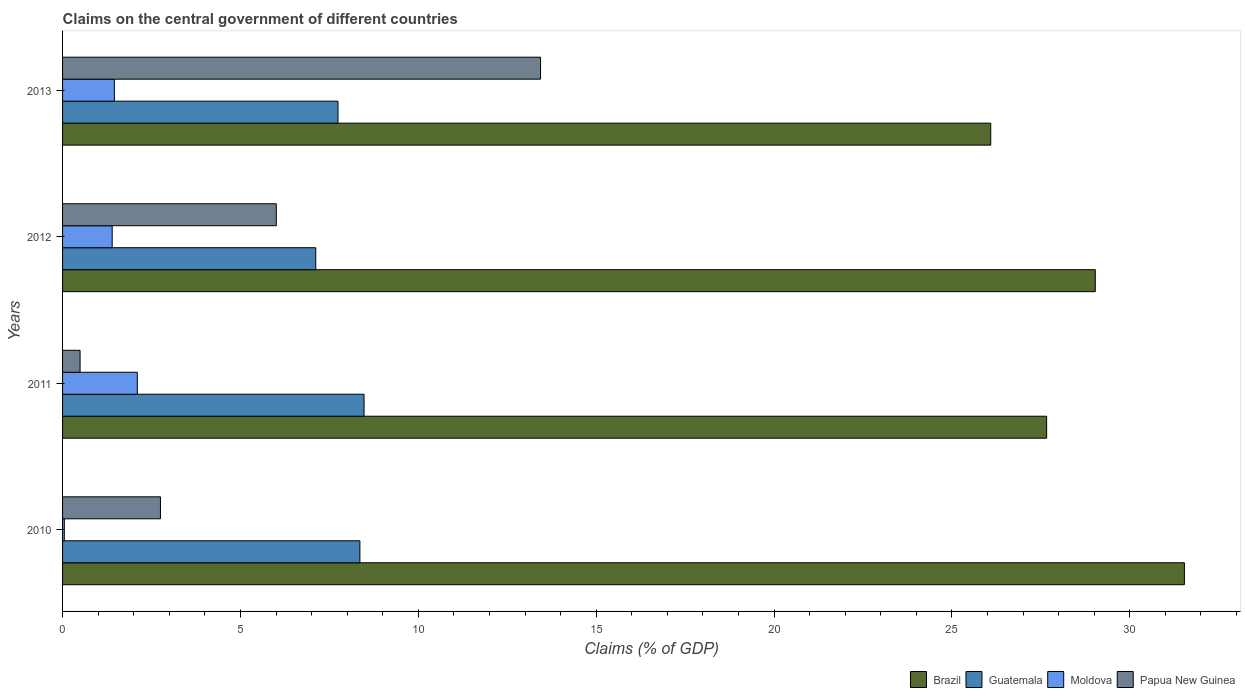How many different coloured bars are there?
Provide a succinct answer. 4. How many groups of bars are there?
Your answer should be very brief. 4. Are the number of bars on each tick of the Y-axis equal?
Your answer should be compact. Yes. How many bars are there on the 4th tick from the top?
Provide a succinct answer. 4. How many bars are there on the 3rd tick from the bottom?
Give a very brief answer. 4. What is the label of the 1st group of bars from the top?
Ensure brevity in your answer.  2013. What is the percentage of GDP claimed on the central government in Guatemala in 2010?
Your response must be concise. 8.36. Across all years, what is the maximum percentage of GDP claimed on the central government in Guatemala?
Keep it short and to the point. 8.47. Across all years, what is the minimum percentage of GDP claimed on the central government in Guatemala?
Give a very brief answer. 7.12. In which year was the percentage of GDP claimed on the central government in Guatemala maximum?
Provide a short and direct response. 2011. In which year was the percentage of GDP claimed on the central government in Brazil minimum?
Make the answer very short. 2013. What is the total percentage of GDP claimed on the central government in Moldova in the graph?
Provide a short and direct response. 5. What is the difference between the percentage of GDP claimed on the central government in Papua New Guinea in 2010 and that in 2013?
Provide a succinct answer. -10.68. What is the difference between the percentage of GDP claimed on the central government in Brazil in 2011 and the percentage of GDP claimed on the central government in Guatemala in 2013?
Give a very brief answer. 19.92. What is the average percentage of GDP claimed on the central government in Guatemala per year?
Provide a short and direct response. 7.92. In the year 2010, what is the difference between the percentage of GDP claimed on the central government in Guatemala and percentage of GDP claimed on the central government in Moldova?
Provide a succinct answer. 8.31. In how many years, is the percentage of GDP claimed on the central government in Moldova greater than 32 %?
Provide a succinct answer. 0. What is the ratio of the percentage of GDP claimed on the central government in Guatemala in 2010 to that in 2013?
Offer a terse response. 1.08. Is the percentage of GDP claimed on the central government in Brazil in 2010 less than that in 2012?
Provide a succinct answer. No. What is the difference between the highest and the second highest percentage of GDP claimed on the central government in Papua New Guinea?
Offer a terse response. 7.43. What is the difference between the highest and the lowest percentage of GDP claimed on the central government in Guatemala?
Your answer should be very brief. 1.36. In how many years, is the percentage of GDP claimed on the central government in Papua New Guinea greater than the average percentage of GDP claimed on the central government in Papua New Guinea taken over all years?
Your answer should be compact. 2. Is the sum of the percentage of GDP claimed on the central government in Guatemala in 2012 and 2013 greater than the maximum percentage of GDP claimed on the central government in Papua New Guinea across all years?
Provide a succinct answer. Yes. What does the 1st bar from the top in 2011 represents?
Offer a very short reply. Papua New Guinea. What does the 2nd bar from the bottom in 2012 represents?
Your response must be concise. Guatemala. Is it the case that in every year, the sum of the percentage of GDP claimed on the central government in Guatemala and percentage of GDP claimed on the central government in Papua New Guinea is greater than the percentage of GDP claimed on the central government in Moldova?
Keep it short and to the point. Yes. How many bars are there?
Offer a very short reply. 16. What is the difference between two consecutive major ticks on the X-axis?
Keep it short and to the point. 5. How are the legend labels stacked?
Keep it short and to the point. Horizontal. What is the title of the graph?
Your answer should be compact. Claims on the central government of different countries. What is the label or title of the X-axis?
Provide a succinct answer. Claims (% of GDP). What is the label or title of the Y-axis?
Your response must be concise. Years. What is the Claims (% of GDP) of Brazil in 2010?
Your answer should be compact. 31.53. What is the Claims (% of GDP) of Guatemala in 2010?
Provide a short and direct response. 8.36. What is the Claims (% of GDP) of Moldova in 2010?
Provide a succinct answer. 0.05. What is the Claims (% of GDP) of Papua New Guinea in 2010?
Ensure brevity in your answer.  2.75. What is the Claims (% of GDP) of Brazil in 2011?
Provide a short and direct response. 27.66. What is the Claims (% of GDP) in Guatemala in 2011?
Make the answer very short. 8.47. What is the Claims (% of GDP) in Moldova in 2011?
Ensure brevity in your answer.  2.1. What is the Claims (% of GDP) of Papua New Guinea in 2011?
Provide a short and direct response. 0.49. What is the Claims (% of GDP) in Brazil in 2012?
Provide a short and direct response. 29.03. What is the Claims (% of GDP) of Guatemala in 2012?
Provide a succinct answer. 7.12. What is the Claims (% of GDP) in Moldova in 2012?
Provide a short and direct response. 1.39. What is the Claims (% of GDP) in Papua New Guinea in 2012?
Provide a short and direct response. 6.01. What is the Claims (% of GDP) in Brazil in 2013?
Your answer should be very brief. 26.09. What is the Claims (% of GDP) of Guatemala in 2013?
Ensure brevity in your answer.  7.74. What is the Claims (% of GDP) in Moldova in 2013?
Your answer should be very brief. 1.46. What is the Claims (% of GDP) of Papua New Guinea in 2013?
Offer a very short reply. 13.44. Across all years, what is the maximum Claims (% of GDP) of Brazil?
Provide a succinct answer. 31.53. Across all years, what is the maximum Claims (% of GDP) in Guatemala?
Your answer should be compact. 8.47. Across all years, what is the maximum Claims (% of GDP) in Moldova?
Your answer should be compact. 2.1. Across all years, what is the maximum Claims (% of GDP) in Papua New Guinea?
Ensure brevity in your answer.  13.44. Across all years, what is the minimum Claims (% of GDP) in Brazil?
Offer a terse response. 26.09. Across all years, what is the minimum Claims (% of GDP) in Guatemala?
Keep it short and to the point. 7.12. Across all years, what is the minimum Claims (% of GDP) in Moldova?
Offer a very short reply. 0.05. Across all years, what is the minimum Claims (% of GDP) in Papua New Guinea?
Ensure brevity in your answer.  0.49. What is the total Claims (% of GDP) of Brazil in the graph?
Your answer should be compact. 114.32. What is the total Claims (% of GDP) of Guatemala in the graph?
Your response must be concise. 31.69. What is the total Claims (% of GDP) in Moldova in the graph?
Provide a short and direct response. 5. What is the total Claims (% of GDP) of Papua New Guinea in the graph?
Your answer should be compact. 22.69. What is the difference between the Claims (% of GDP) in Brazil in 2010 and that in 2011?
Your response must be concise. 3.87. What is the difference between the Claims (% of GDP) of Guatemala in 2010 and that in 2011?
Make the answer very short. -0.12. What is the difference between the Claims (% of GDP) of Moldova in 2010 and that in 2011?
Your response must be concise. -2.05. What is the difference between the Claims (% of GDP) in Papua New Guinea in 2010 and that in 2011?
Your answer should be compact. 2.26. What is the difference between the Claims (% of GDP) of Brazil in 2010 and that in 2012?
Offer a terse response. 2.51. What is the difference between the Claims (% of GDP) of Guatemala in 2010 and that in 2012?
Provide a short and direct response. 1.24. What is the difference between the Claims (% of GDP) of Moldova in 2010 and that in 2012?
Your answer should be very brief. -1.35. What is the difference between the Claims (% of GDP) in Papua New Guinea in 2010 and that in 2012?
Provide a succinct answer. -3.26. What is the difference between the Claims (% of GDP) of Brazil in 2010 and that in 2013?
Your answer should be very brief. 5.44. What is the difference between the Claims (% of GDP) of Guatemala in 2010 and that in 2013?
Offer a very short reply. 0.62. What is the difference between the Claims (% of GDP) in Moldova in 2010 and that in 2013?
Your answer should be very brief. -1.41. What is the difference between the Claims (% of GDP) in Papua New Guinea in 2010 and that in 2013?
Your answer should be very brief. -10.68. What is the difference between the Claims (% of GDP) of Brazil in 2011 and that in 2012?
Your answer should be compact. -1.37. What is the difference between the Claims (% of GDP) of Guatemala in 2011 and that in 2012?
Offer a very short reply. 1.36. What is the difference between the Claims (% of GDP) in Moldova in 2011 and that in 2012?
Offer a very short reply. 0.71. What is the difference between the Claims (% of GDP) of Papua New Guinea in 2011 and that in 2012?
Ensure brevity in your answer.  -5.52. What is the difference between the Claims (% of GDP) of Brazil in 2011 and that in 2013?
Provide a short and direct response. 1.57. What is the difference between the Claims (% of GDP) of Guatemala in 2011 and that in 2013?
Keep it short and to the point. 0.73. What is the difference between the Claims (% of GDP) of Moldova in 2011 and that in 2013?
Make the answer very short. 0.64. What is the difference between the Claims (% of GDP) in Papua New Guinea in 2011 and that in 2013?
Give a very brief answer. -12.94. What is the difference between the Claims (% of GDP) in Brazil in 2012 and that in 2013?
Your answer should be very brief. 2.94. What is the difference between the Claims (% of GDP) in Guatemala in 2012 and that in 2013?
Provide a short and direct response. -0.63. What is the difference between the Claims (% of GDP) in Moldova in 2012 and that in 2013?
Give a very brief answer. -0.06. What is the difference between the Claims (% of GDP) of Papua New Guinea in 2012 and that in 2013?
Your answer should be compact. -7.43. What is the difference between the Claims (% of GDP) in Brazil in 2010 and the Claims (% of GDP) in Guatemala in 2011?
Provide a succinct answer. 23.06. What is the difference between the Claims (% of GDP) of Brazil in 2010 and the Claims (% of GDP) of Moldova in 2011?
Provide a succinct answer. 29.43. What is the difference between the Claims (% of GDP) of Brazil in 2010 and the Claims (% of GDP) of Papua New Guinea in 2011?
Keep it short and to the point. 31.04. What is the difference between the Claims (% of GDP) in Guatemala in 2010 and the Claims (% of GDP) in Moldova in 2011?
Provide a succinct answer. 6.26. What is the difference between the Claims (% of GDP) in Guatemala in 2010 and the Claims (% of GDP) in Papua New Guinea in 2011?
Provide a short and direct response. 7.87. What is the difference between the Claims (% of GDP) of Moldova in 2010 and the Claims (% of GDP) of Papua New Guinea in 2011?
Your answer should be very brief. -0.44. What is the difference between the Claims (% of GDP) in Brazil in 2010 and the Claims (% of GDP) in Guatemala in 2012?
Make the answer very short. 24.42. What is the difference between the Claims (% of GDP) of Brazil in 2010 and the Claims (% of GDP) of Moldova in 2012?
Your response must be concise. 30.14. What is the difference between the Claims (% of GDP) of Brazil in 2010 and the Claims (% of GDP) of Papua New Guinea in 2012?
Your response must be concise. 25.53. What is the difference between the Claims (% of GDP) of Guatemala in 2010 and the Claims (% of GDP) of Moldova in 2012?
Offer a very short reply. 6.96. What is the difference between the Claims (% of GDP) of Guatemala in 2010 and the Claims (% of GDP) of Papua New Guinea in 2012?
Keep it short and to the point. 2.35. What is the difference between the Claims (% of GDP) of Moldova in 2010 and the Claims (% of GDP) of Papua New Guinea in 2012?
Make the answer very short. -5.96. What is the difference between the Claims (% of GDP) of Brazil in 2010 and the Claims (% of GDP) of Guatemala in 2013?
Your answer should be compact. 23.79. What is the difference between the Claims (% of GDP) in Brazil in 2010 and the Claims (% of GDP) in Moldova in 2013?
Provide a succinct answer. 30.08. What is the difference between the Claims (% of GDP) in Brazil in 2010 and the Claims (% of GDP) in Papua New Guinea in 2013?
Ensure brevity in your answer.  18.1. What is the difference between the Claims (% of GDP) in Guatemala in 2010 and the Claims (% of GDP) in Moldova in 2013?
Ensure brevity in your answer.  6.9. What is the difference between the Claims (% of GDP) of Guatemala in 2010 and the Claims (% of GDP) of Papua New Guinea in 2013?
Make the answer very short. -5.08. What is the difference between the Claims (% of GDP) of Moldova in 2010 and the Claims (% of GDP) of Papua New Guinea in 2013?
Provide a succinct answer. -13.39. What is the difference between the Claims (% of GDP) of Brazil in 2011 and the Claims (% of GDP) of Guatemala in 2012?
Provide a succinct answer. 20.54. What is the difference between the Claims (% of GDP) in Brazil in 2011 and the Claims (% of GDP) in Moldova in 2012?
Make the answer very short. 26.27. What is the difference between the Claims (% of GDP) in Brazil in 2011 and the Claims (% of GDP) in Papua New Guinea in 2012?
Keep it short and to the point. 21.65. What is the difference between the Claims (% of GDP) of Guatemala in 2011 and the Claims (% of GDP) of Moldova in 2012?
Your answer should be very brief. 7.08. What is the difference between the Claims (% of GDP) in Guatemala in 2011 and the Claims (% of GDP) in Papua New Guinea in 2012?
Your response must be concise. 2.47. What is the difference between the Claims (% of GDP) of Moldova in 2011 and the Claims (% of GDP) of Papua New Guinea in 2012?
Your answer should be compact. -3.91. What is the difference between the Claims (% of GDP) of Brazil in 2011 and the Claims (% of GDP) of Guatemala in 2013?
Your response must be concise. 19.92. What is the difference between the Claims (% of GDP) in Brazil in 2011 and the Claims (% of GDP) in Moldova in 2013?
Your response must be concise. 26.21. What is the difference between the Claims (% of GDP) of Brazil in 2011 and the Claims (% of GDP) of Papua New Guinea in 2013?
Your answer should be very brief. 14.23. What is the difference between the Claims (% of GDP) of Guatemala in 2011 and the Claims (% of GDP) of Moldova in 2013?
Offer a terse response. 7.02. What is the difference between the Claims (% of GDP) in Guatemala in 2011 and the Claims (% of GDP) in Papua New Guinea in 2013?
Give a very brief answer. -4.96. What is the difference between the Claims (% of GDP) of Moldova in 2011 and the Claims (% of GDP) of Papua New Guinea in 2013?
Keep it short and to the point. -11.33. What is the difference between the Claims (% of GDP) in Brazil in 2012 and the Claims (% of GDP) in Guatemala in 2013?
Keep it short and to the point. 21.29. What is the difference between the Claims (% of GDP) of Brazil in 2012 and the Claims (% of GDP) of Moldova in 2013?
Provide a succinct answer. 27.57. What is the difference between the Claims (% of GDP) of Brazil in 2012 and the Claims (% of GDP) of Papua New Guinea in 2013?
Keep it short and to the point. 15.59. What is the difference between the Claims (% of GDP) of Guatemala in 2012 and the Claims (% of GDP) of Moldova in 2013?
Provide a succinct answer. 5.66. What is the difference between the Claims (% of GDP) of Guatemala in 2012 and the Claims (% of GDP) of Papua New Guinea in 2013?
Offer a very short reply. -6.32. What is the difference between the Claims (% of GDP) of Moldova in 2012 and the Claims (% of GDP) of Papua New Guinea in 2013?
Offer a very short reply. -12.04. What is the average Claims (% of GDP) of Brazil per year?
Your answer should be compact. 28.58. What is the average Claims (% of GDP) of Guatemala per year?
Give a very brief answer. 7.92. What is the average Claims (% of GDP) of Moldova per year?
Give a very brief answer. 1.25. What is the average Claims (% of GDP) of Papua New Guinea per year?
Ensure brevity in your answer.  5.67. In the year 2010, what is the difference between the Claims (% of GDP) of Brazil and Claims (% of GDP) of Guatemala?
Offer a terse response. 23.18. In the year 2010, what is the difference between the Claims (% of GDP) of Brazil and Claims (% of GDP) of Moldova?
Ensure brevity in your answer.  31.48. In the year 2010, what is the difference between the Claims (% of GDP) in Brazil and Claims (% of GDP) in Papua New Guinea?
Make the answer very short. 28.78. In the year 2010, what is the difference between the Claims (% of GDP) of Guatemala and Claims (% of GDP) of Moldova?
Offer a terse response. 8.31. In the year 2010, what is the difference between the Claims (% of GDP) in Guatemala and Claims (% of GDP) in Papua New Guinea?
Ensure brevity in your answer.  5.61. In the year 2010, what is the difference between the Claims (% of GDP) of Moldova and Claims (% of GDP) of Papua New Guinea?
Your response must be concise. -2.7. In the year 2011, what is the difference between the Claims (% of GDP) of Brazil and Claims (% of GDP) of Guatemala?
Your answer should be very brief. 19.19. In the year 2011, what is the difference between the Claims (% of GDP) in Brazil and Claims (% of GDP) in Moldova?
Your response must be concise. 25.56. In the year 2011, what is the difference between the Claims (% of GDP) of Brazil and Claims (% of GDP) of Papua New Guinea?
Offer a very short reply. 27.17. In the year 2011, what is the difference between the Claims (% of GDP) of Guatemala and Claims (% of GDP) of Moldova?
Offer a terse response. 6.37. In the year 2011, what is the difference between the Claims (% of GDP) of Guatemala and Claims (% of GDP) of Papua New Guinea?
Offer a terse response. 7.98. In the year 2011, what is the difference between the Claims (% of GDP) in Moldova and Claims (% of GDP) in Papua New Guinea?
Keep it short and to the point. 1.61. In the year 2012, what is the difference between the Claims (% of GDP) of Brazil and Claims (% of GDP) of Guatemala?
Offer a very short reply. 21.91. In the year 2012, what is the difference between the Claims (% of GDP) of Brazil and Claims (% of GDP) of Moldova?
Ensure brevity in your answer.  27.63. In the year 2012, what is the difference between the Claims (% of GDP) of Brazil and Claims (% of GDP) of Papua New Guinea?
Offer a very short reply. 23.02. In the year 2012, what is the difference between the Claims (% of GDP) of Guatemala and Claims (% of GDP) of Moldova?
Your answer should be very brief. 5.72. In the year 2012, what is the difference between the Claims (% of GDP) of Guatemala and Claims (% of GDP) of Papua New Guinea?
Your answer should be very brief. 1.11. In the year 2012, what is the difference between the Claims (% of GDP) in Moldova and Claims (% of GDP) in Papua New Guinea?
Your answer should be very brief. -4.61. In the year 2013, what is the difference between the Claims (% of GDP) in Brazil and Claims (% of GDP) in Guatemala?
Keep it short and to the point. 18.35. In the year 2013, what is the difference between the Claims (% of GDP) of Brazil and Claims (% of GDP) of Moldova?
Offer a terse response. 24.63. In the year 2013, what is the difference between the Claims (% of GDP) of Brazil and Claims (% of GDP) of Papua New Guinea?
Offer a very short reply. 12.65. In the year 2013, what is the difference between the Claims (% of GDP) in Guatemala and Claims (% of GDP) in Moldova?
Your answer should be compact. 6.29. In the year 2013, what is the difference between the Claims (% of GDP) in Guatemala and Claims (% of GDP) in Papua New Guinea?
Make the answer very short. -5.69. In the year 2013, what is the difference between the Claims (% of GDP) in Moldova and Claims (% of GDP) in Papua New Guinea?
Give a very brief answer. -11.98. What is the ratio of the Claims (% of GDP) in Brazil in 2010 to that in 2011?
Your answer should be compact. 1.14. What is the ratio of the Claims (% of GDP) in Guatemala in 2010 to that in 2011?
Offer a very short reply. 0.99. What is the ratio of the Claims (% of GDP) in Moldova in 2010 to that in 2011?
Your response must be concise. 0.02. What is the ratio of the Claims (% of GDP) in Papua New Guinea in 2010 to that in 2011?
Give a very brief answer. 5.59. What is the ratio of the Claims (% of GDP) of Brazil in 2010 to that in 2012?
Make the answer very short. 1.09. What is the ratio of the Claims (% of GDP) in Guatemala in 2010 to that in 2012?
Make the answer very short. 1.17. What is the ratio of the Claims (% of GDP) in Moldova in 2010 to that in 2012?
Provide a succinct answer. 0.04. What is the ratio of the Claims (% of GDP) of Papua New Guinea in 2010 to that in 2012?
Provide a succinct answer. 0.46. What is the ratio of the Claims (% of GDP) in Brazil in 2010 to that in 2013?
Your answer should be compact. 1.21. What is the ratio of the Claims (% of GDP) in Guatemala in 2010 to that in 2013?
Your response must be concise. 1.08. What is the ratio of the Claims (% of GDP) in Moldova in 2010 to that in 2013?
Your response must be concise. 0.03. What is the ratio of the Claims (% of GDP) of Papua New Guinea in 2010 to that in 2013?
Your answer should be compact. 0.2. What is the ratio of the Claims (% of GDP) in Brazil in 2011 to that in 2012?
Offer a very short reply. 0.95. What is the ratio of the Claims (% of GDP) in Guatemala in 2011 to that in 2012?
Ensure brevity in your answer.  1.19. What is the ratio of the Claims (% of GDP) in Moldova in 2011 to that in 2012?
Make the answer very short. 1.51. What is the ratio of the Claims (% of GDP) of Papua New Guinea in 2011 to that in 2012?
Offer a terse response. 0.08. What is the ratio of the Claims (% of GDP) in Brazil in 2011 to that in 2013?
Provide a succinct answer. 1.06. What is the ratio of the Claims (% of GDP) of Guatemala in 2011 to that in 2013?
Ensure brevity in your answer.  1.09. What is the ratio of the Claims (% of GDP) in Moldova in 2011 to that in 2013?
Your answer should be compact. 1.44. What is the ratio of the Claims (% of GDP) of Papua New Guinea in 2011 to that in 2013?
Provide a short and direct response. 0.04. What is the ratio of the Claims (% of GDP) of Brazil in 2012 to that in 2013?
Make the answer very short. 1.11. What is the ratio of the Claims (% of GDP) in Guatemala in 2012 to that in 2013?
Keep it short and to the point. 0.92. What is the ratio of the Claims (% of GDP) of Moldova in 2012 to that in 2013?
Provide a succinct answer. 0.96. What is the ratio of the Claims (% of GDP) in Papua New Guinea in 2012 to that in 2013?
Give a very brief answer. 0.45. What is the difference between the highest and the second highest Claims (% of GDP) in Brazil?
Make the answer very short. 2.51. What is the difference between the highest and the second highest Claims (% of GDP) in Guatemala?
Offer a very short reply. 0.12. What is the difference between the highest and the second highest Claims (% of GDP) of Moldova?
Provide a succinct answer. 0.64. What is the difference between the highest and the second highest Claims (% of GDP) of Papua New Guinea?
Make the answer very short. 7.43. What is the difference between the highest and the lowest Claims (% of GDP) in Brazil?
Your response must be concise. 5.44. What is the difference between the highest and the lowest Claims (% of GDP) in Guatemala?
Ensure brevity in your answer.  1.36. What is the difference between the highest and the lowest Claims (% of GDP) of Moldova?
Make the answer very short. 2.05. What is the difference between the highest and the lowest Claims (% of GDP) in Papua New Guinea?
Give a very brief answer. 12.94. 